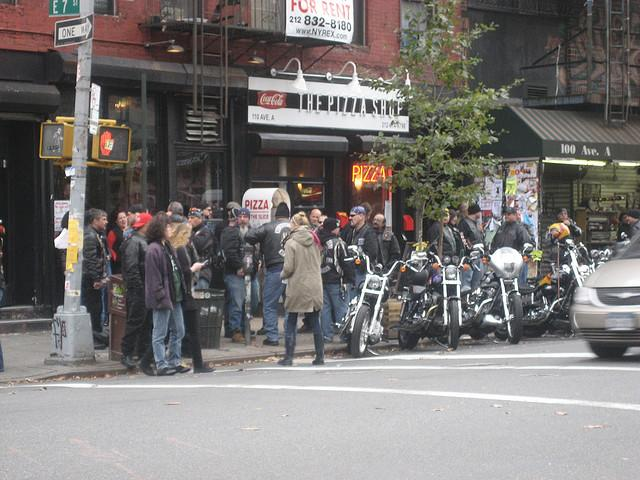What will the bikers shown here have for lunch today? Please explain your reasoning. pizza. They are at a pizza place. 